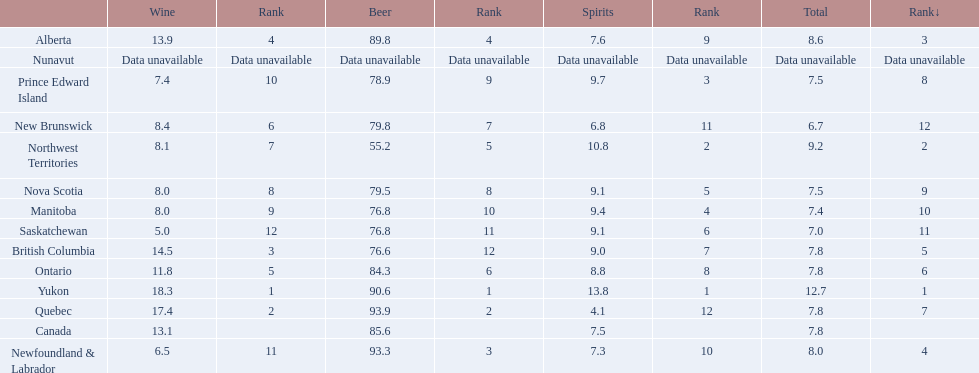Which locations consume the same total amount of alcoholic beverages as another location? British Columbia, Ontario, Quebec, Prince Edward Island, Nova Scotia. Which of these consumes more then 80 of beer? Ontario, Quebec. Of those what was the consumption of spirits of the one that consumed the most beer? 4.1. 